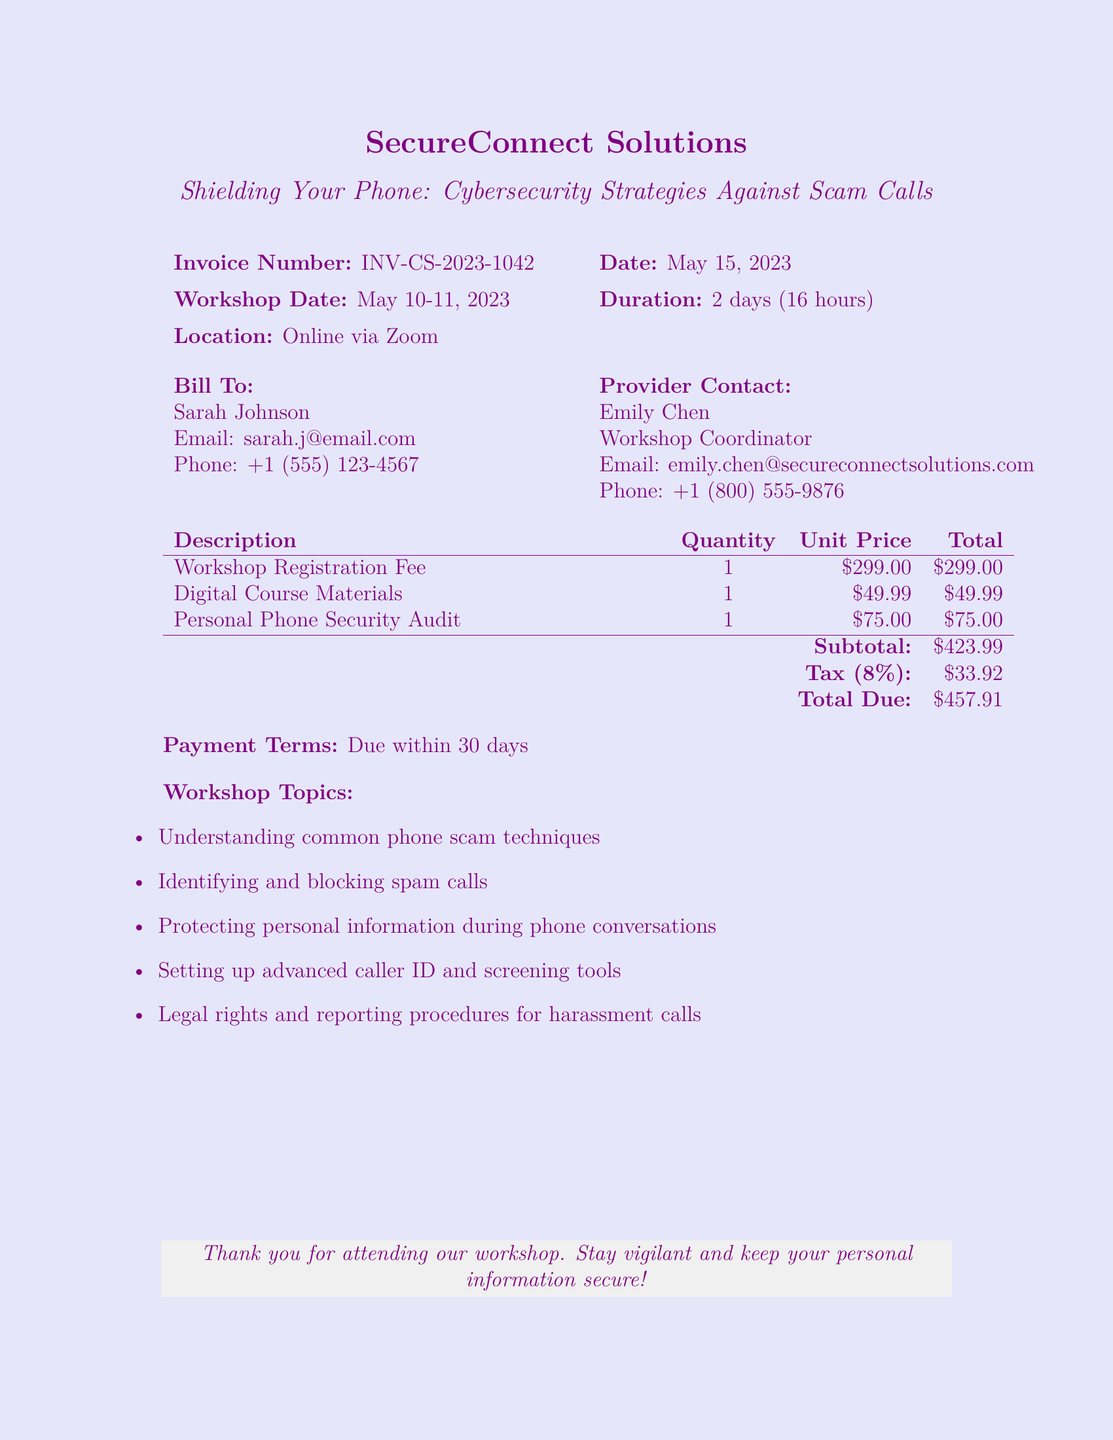What is the invoice number? The invoice number is stated at the top of the document.
Answer: INV-CS-2023-1042 What is the total due amount? The total due amount is calculated after adding the subtotal and tax.
Answer: $457.91 Who is the workshop coordinator? The document specifies the provider contact details including the coordinator's name.
Answer: Emily Chen What is the quantity for the digital course materials? The quantity for each line item is listed in the table.
Answer: 1 What is the workshop date? The workshop date is mentioned in the header of the invoice.
Answer: May 10-11, 2023 How much is charged for the personal phone security audit? Each item in the invoice lists its respective price.
Answer: $75.00 What topics are covered in the workshop? The document lists several topics related to phone scams in an itemized format.
Answer: Understanding common phone scam techniques What is the tax percentage applied to the invoice? The tax rate is specifically mentioned in the calculations section of the document.
Answer: 8% What is the payment term for the invoice? The payment terms are mentioned towards the end of the document.
Answer: Due within 30 days 